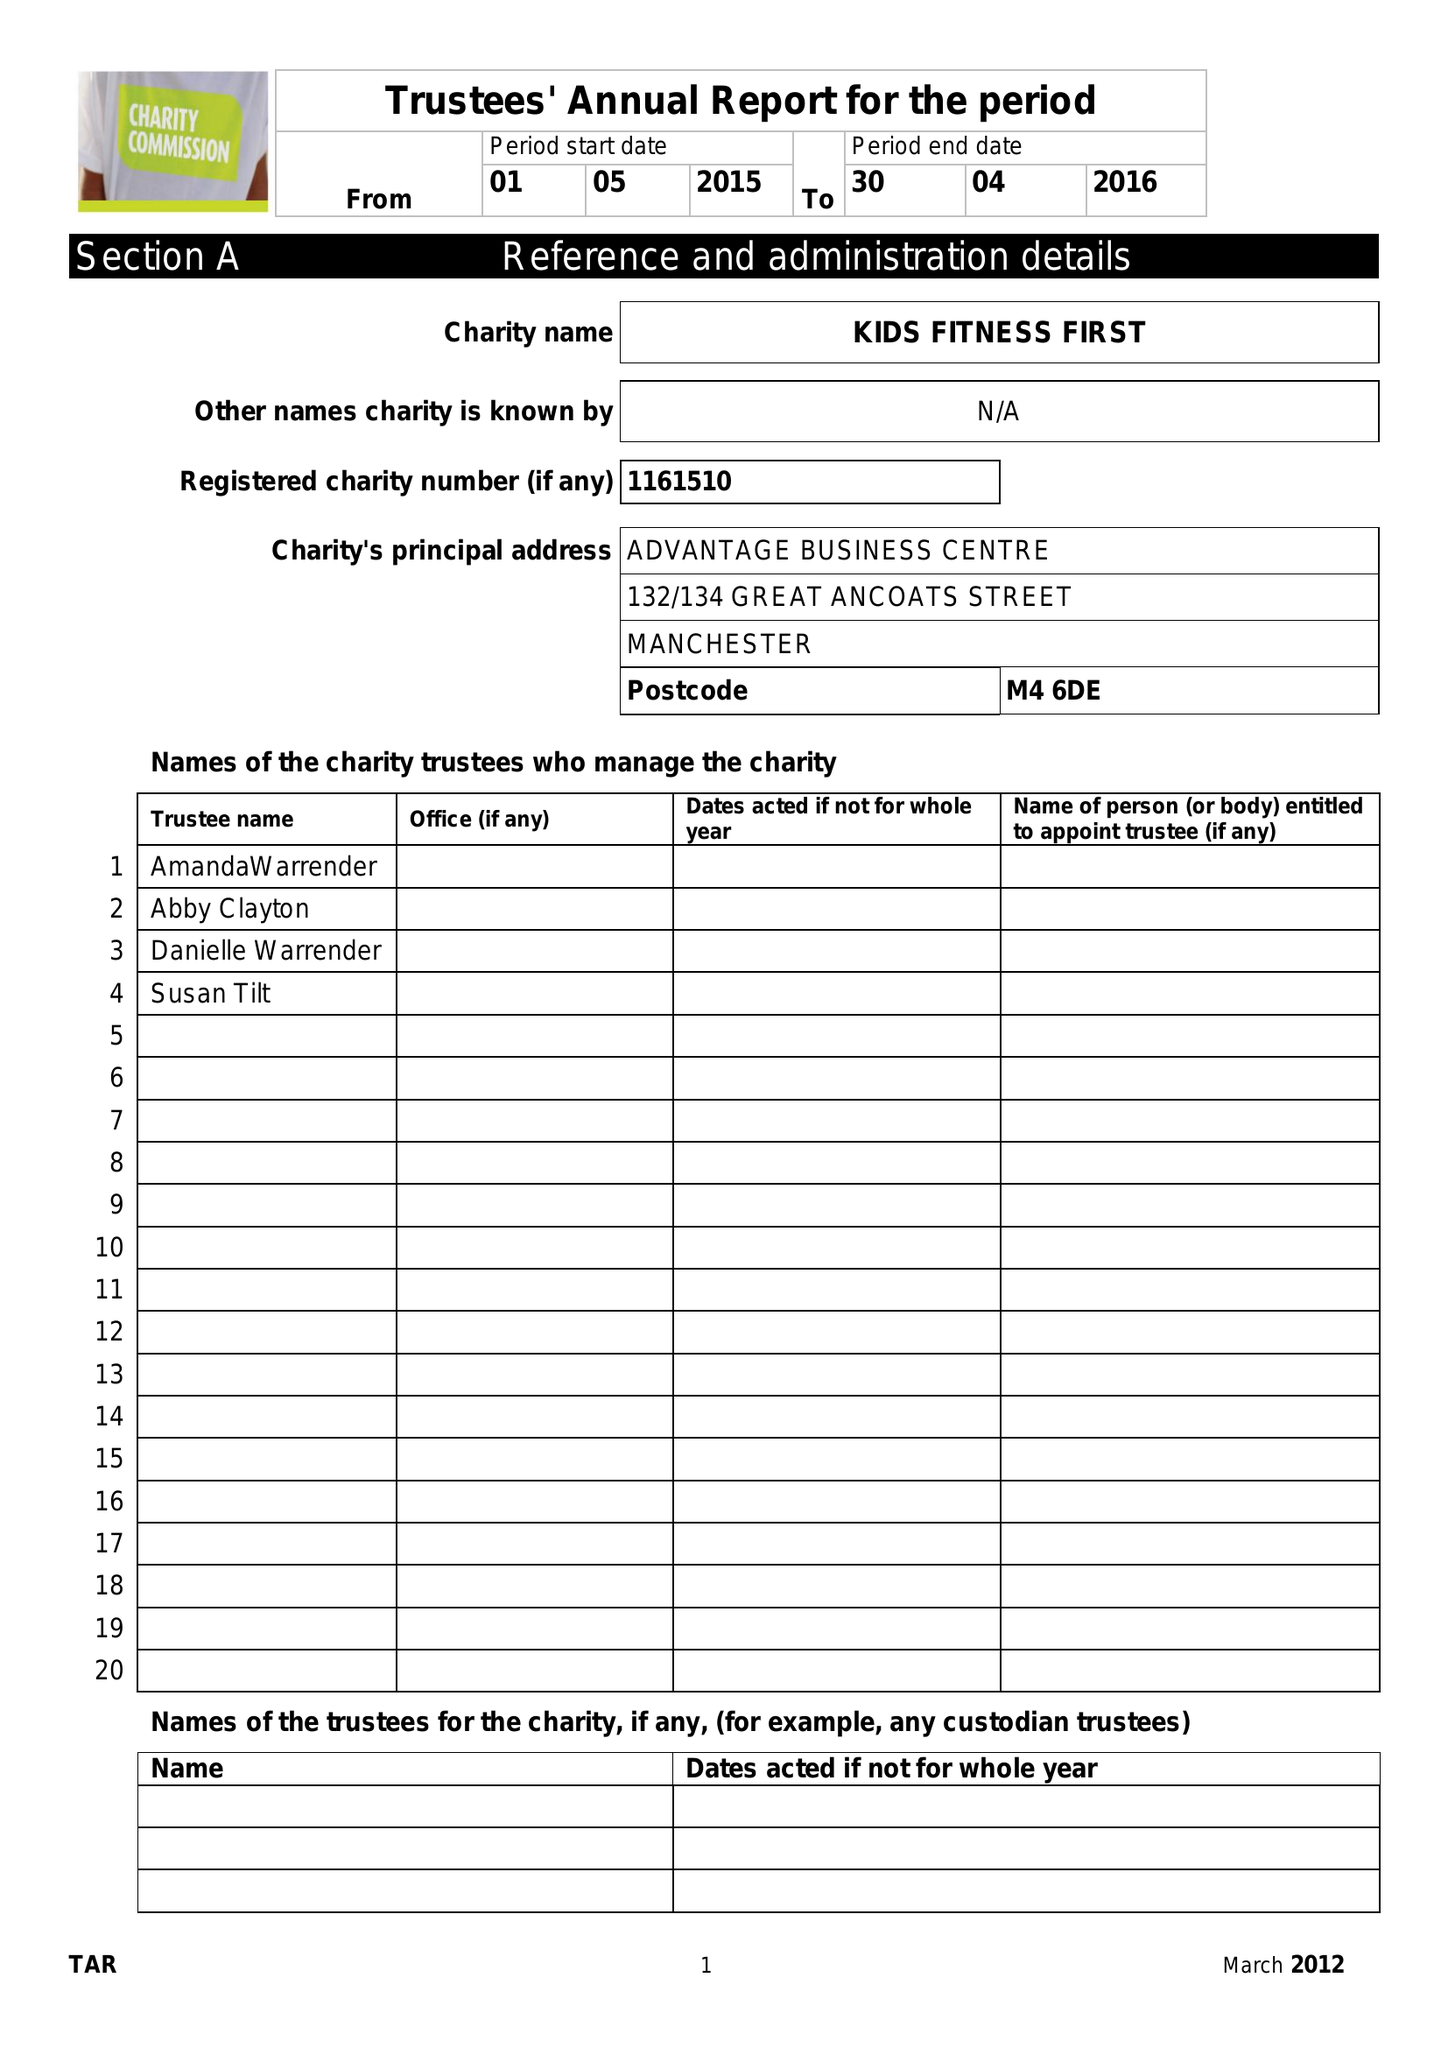What is the value for the address__postcode?
Answer the question using a single word or phrase. M4 6DE 